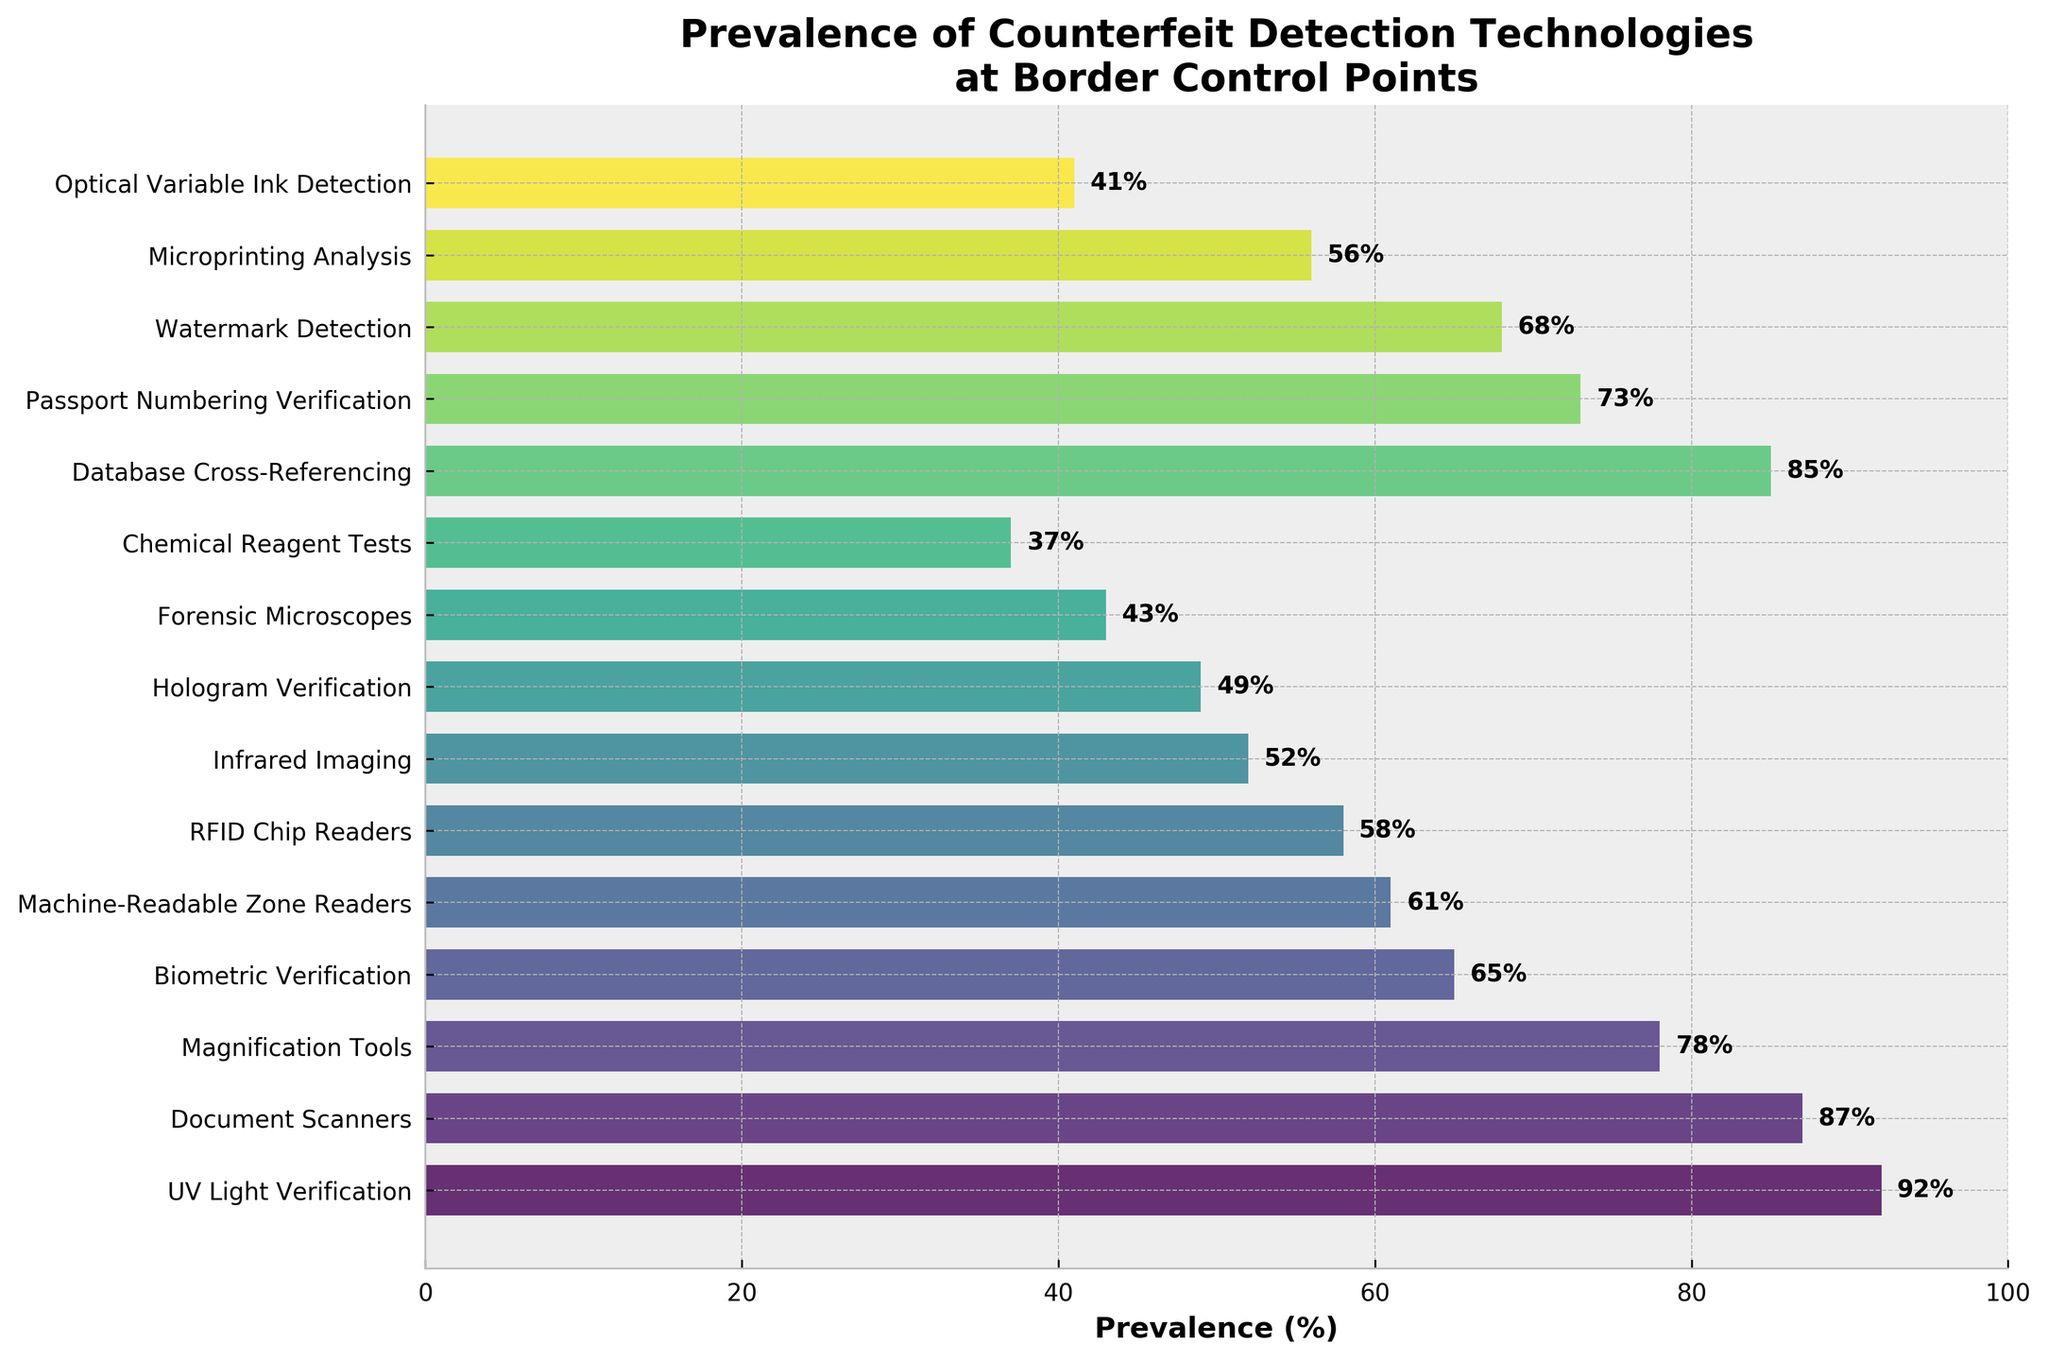What is the most prevalent counterfeit detection technology according to the figure? The tallest bar on the chart represents the most prevalent technology. UV Light Verification has a 92% prevalence, making it the most common tool.
Answer: UV Light Verification Which technology is less prevalent: Machine-Readable Zone Readers or RFID Chip Readers? To determine which technology is less prevalent, compare the heights of the corresponding bars. Machine-Readable Zone Readers have a 61% prevalence, while RFID Chip Readers have a 58% prevalence. RFID Chip Readers are less prevalent.
Answer: RFID Chip Readers What is the total prevalence percentage of the three least common technologies? Identify the three shortest bars corresponding to Optical Variable Ink Detection, Forensic Microscopes, and Chemical Reagent Tests, with prevalences of 41%, 43%, and 37%, respectively. Sum these values: 41 + 43 + 37 = 121.
Answer: 121% What is the difference in prevalence between Biometric Verification and Hologram Verification? Find the respective bars for Biometric Verification and Hologram Verification at 65% and 49%. Subtract the lower prevalence from the higher prevalence: 65% - 49% = 16%.
Answer: 16% Which technology has the closest prevalence to 50%? Examine the bars around the 50% mark. Infrared Imaging has a 52% prevalence, which is closest to 50%.
Answer: Infrared Imaging What is the average prevalence of UV Light Verification, Passport Numbering Verification, and Watermark Detection? Extract the values for these three technologies: UV Light Verification (92%), Passport Numbering Verification (73%), and Watermark Detection (68%). Calculate the average as (92 + 73 + 68) / 3 = 77.67%.
Answer: 77.67% Is Database Cross-Referencing more or less prevalent than Document Scanners? Compare the heights of the bars representing Database Cross-Referencing and Document Scanners. Database Cross-Referencing has a prevalence of 85%, while Document Scanners have 87%. Database Cross-Referencing is less prevalent.
Answer: Less prevalent Between Forensic Microscopes and Magnification Tools, which one is more prevalent and by how much? Forensic Microscopes have a 43% prevalence, and Magnification Tools have a 78% prevalence. The difference is 78% - 43% = 35%. Magnification Tools are more prevalent by 35%.
Answer: Magnification Tools by 35% List all technologies that have a prevalence greater than or equal to 60%. Identify bars with prevalence percentages of 60% or higher: UV Light Verification (92%), Document Scanners (87%), Database Cross-Referencing (85%), Magnification Tools (78%), Passport Numbering Verification (73%), Watermark Detection (68%), and Biometric Verification (65%), Machine-Readable Zone Readers (61%).
Answer: UV Light Verification, Document Scanners, Database Cross-Referencing, Magnification Tools, Passport Numbering Verification, Watermark Detection, Biometric Verification, Machine-Readable Zone Readers Which technologies have a prevalence between 50% and 70%? Identify the bars within the specified range (50% <= prevalence <= 70%): Biometric Verification (65%), Watermark Detection (68%), RFID Chip Readers (58%), Infrared Imaging (52%), and Microprinting Analysis (56%).
Answer: Biometric Verification, Watermark Detection, RFID Chip Readers, Infrared Imaging, Microprinting Analysis 